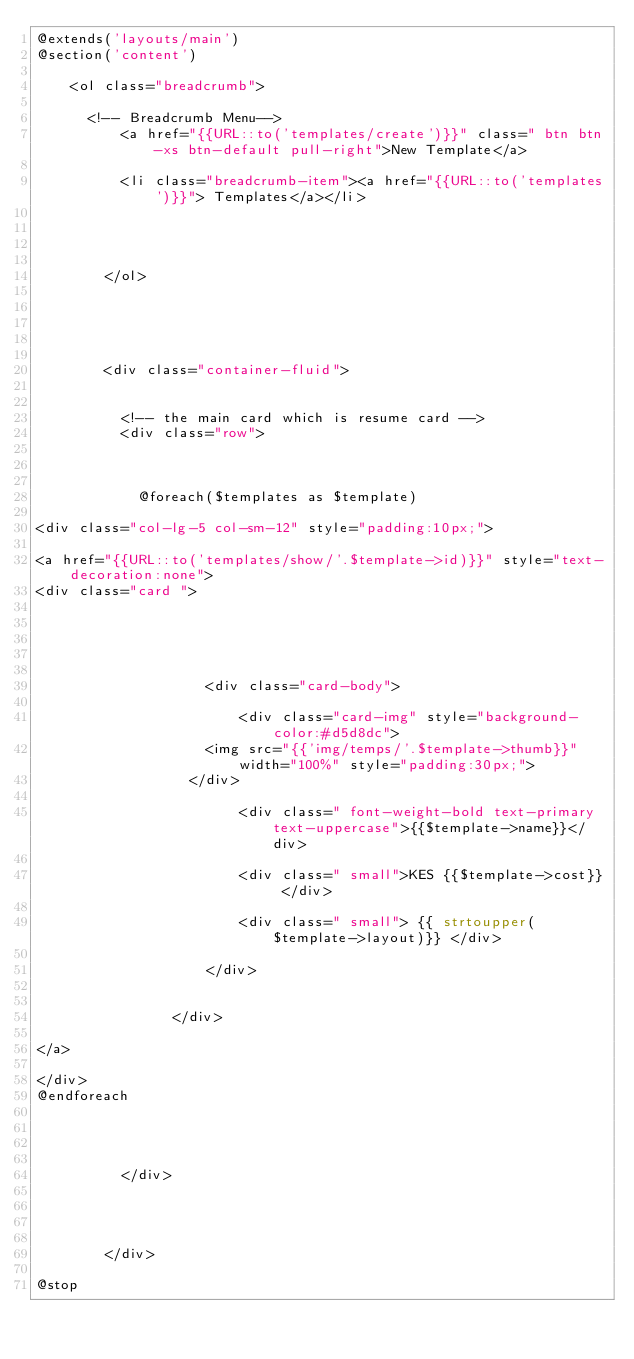<code> <loc_0><loc_0><loc_500><loc_500><_PHP_>@extends('layouts/main')
@section('content')
		
		<ol class="breadcrumb">

      <!-- Breadcrumb Menu-->
          <a href="{{URL::to('templates/create')}}" class=" btn btn-xs btn-default pull-right">New Template</a>
          
          <li class="breadcrumb-item"><a href="{{URL::to('templates')}}"> Templates</a></li>
         
         
         
          
        </ol>

		



        <div class="container-fluid">


        	<!-- the main card which is resume card -->
        	<div class="row">

        		
        		
        		@foreach($templates as $template)

<div class="col-lg-5 col-sm-12" style="padding:10px;">

<a href="{{URL::to('templates/show/'.$template->id)}}" style="text-decoration:none">
<div class="card ">
                 
                      
                   
                    
                    
                    <div class="card-body">
                        
                        <div class="card-img" style="background-color:#d5d8dc">
                    <img src="{{'img/temps/'.$template->thumb}}" width="100%" style="padding:30px;">
                  </div>

                        <div class=" font-weight-bold text-primary text-uppercase">{{$template->name}}</div>

                        <div class=" small">KES {{$template->cost}} </div>

                        <div class=" small"> {{ strtoupper($template->layout)}} </div>
                    
                    </div>

                 
                </div>

</a>

</div>
@endforeach


        	

        	</div>
        	
        	


        </div>

@stop</code> 